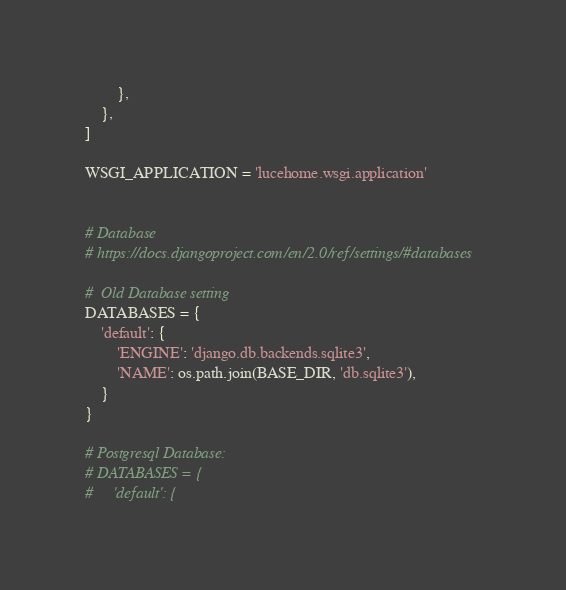Convert code to text. <code><loc_0><loc_0><loc_500><loc_500><_Python_>        },
    },
]

WSGI_APPLICATION = 'lucehome.wsgi.application'


# Database
# https://docs.djangoproject.com/en/2.0/ref/settings/#databases

#  Old Database setting
DATABASES = {
    'default': {
        'ENGINE': 'django.db.backends.sqlite3',
        'NAME': os.path.join(BASE_DIR, 'db.sqlite3'),
    }
}

# Postgresql Database:
# DATABASES = {
#     'default': {</code> 